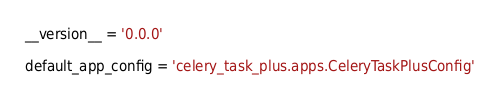<code> <loc_0><loc_0><loc_500><loc_500><_Python_>__version__ = '0.0.0'

default_app_config = 'celery_task_plus.apps.CeleryTaskPlusConfig'
</code> 